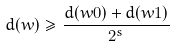<formula> <loc_0><loc_0><loc_500><loc_500>d ( w ) \geq \frac { d ( w 0 ) + d ( w 1 ) } { 2 ^ { s } }</formula> 